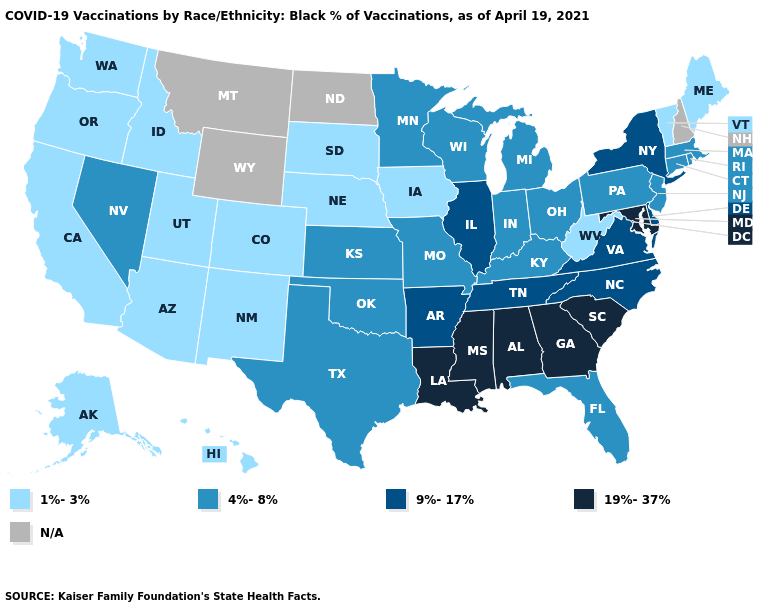What is the value of California?
Be succinct. 1%-3%. Does Nevada have the lowest value in the West?
Concise answer only. No. Is the legend a continuous bar?
Keep it brief. No. Name the states that have a value in the range 1%-3%?
Concise answer only. Alaska, Arizona, California, Colorado, Hawaii, Idaho, Iowa, Maine, Nebraska, New Mexico, Oregon, South Dakota, Utah, Vermont, Washington, West Virginia. What is the value of Minnesota?
Short answer required. 4%-8%. Which states have the lowest value in the USA?
Write a very short answer. Alaska, Arizona, California, Colorado, Hawaii, Idaho, Iowa, Maine, Nebraska, New Mexico, Oregon, South Dakota, Utah, Vermont, Washington, West Virginia. Name the states that have a value in the range 9%-17%?
Give a very brief answer. Arkansas, Delaware, Illinois, New York, North Carolina, Tennessee, Virginia. Does the first symbol in the legend represent the smallest category?
Short answer required. Yes. Name the states that have a value in the range N/A?
Give a very brief answer. Montana, New Hampshire, North Dakota, Wyoming. What is the value of Delaware?
Keep it brief. 9%-17%. Does South Carolina have the highest value in the USA?
Concise answer only. Yes. Name the states that have a value in the range 9%-17%?
Answer briefly. Arkansas, Delaware, Illinois, New York, North Carolina, Tennessee, Virginia. Name the states that have a value in the range 19%-37%?
Answer briefly. Alabama, Georgia, Louisiana, Maryland, Mississippi, South Carolina. 